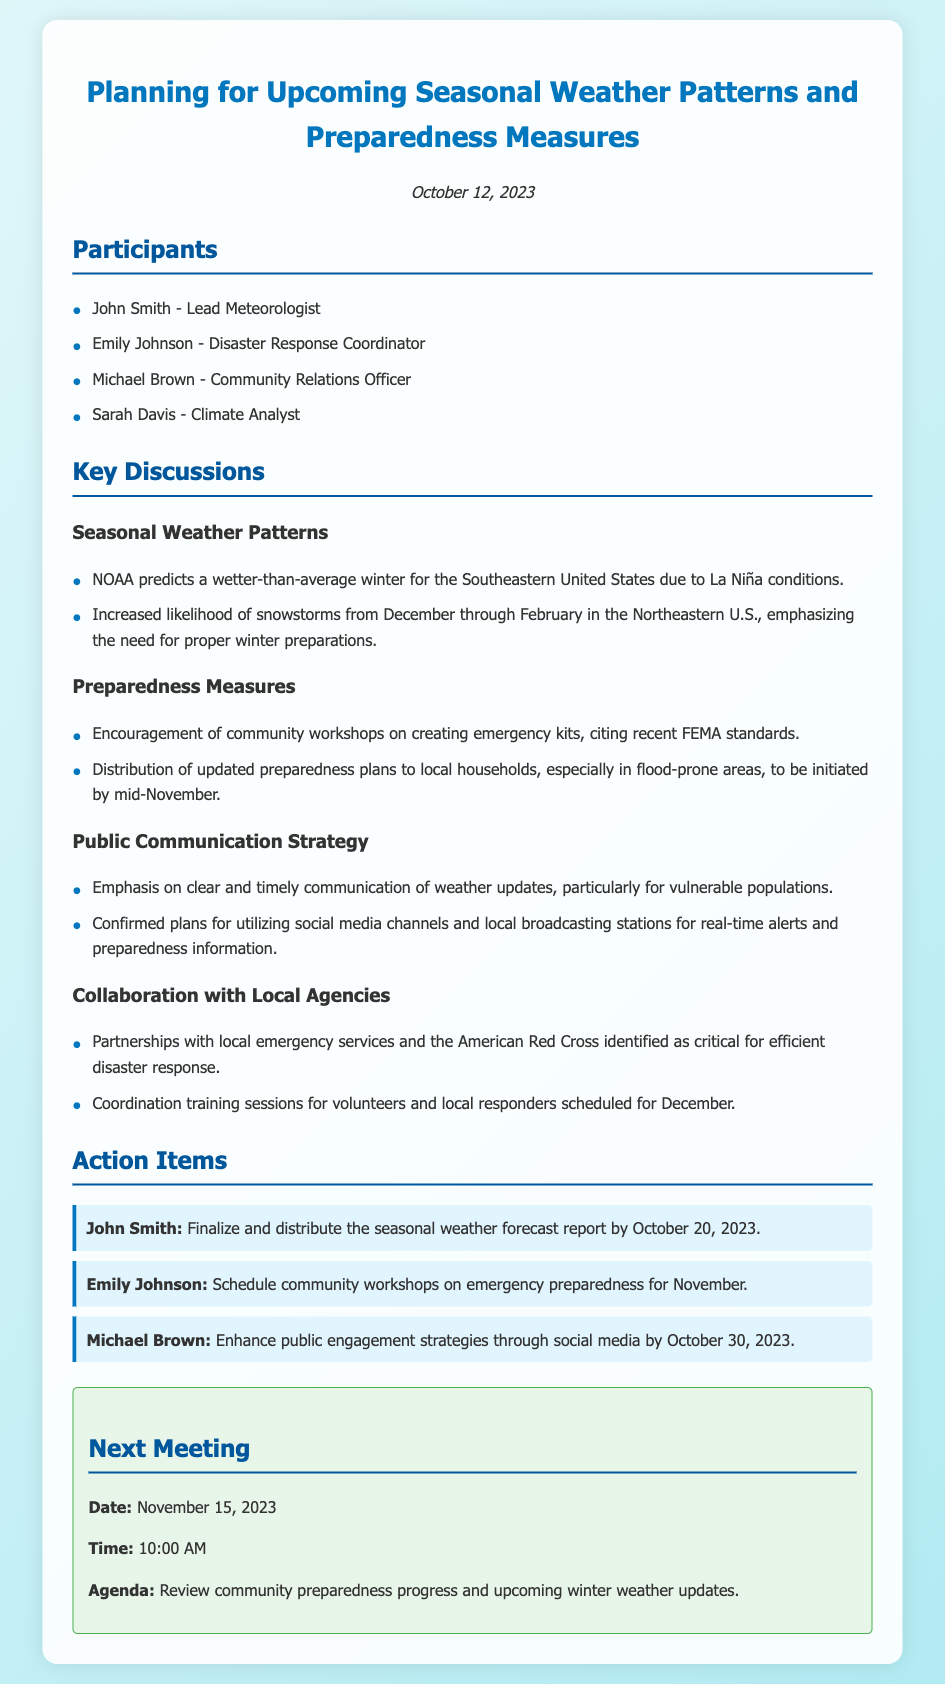What date was the meeting held? The meeting date is mentioned at the top of the document under the date section.
Answer: October 12, 2023 Who is the Lead Meteorologist? The names of participants are listed under the "Participants" section of the document.
Answer: John Smith What weather condition is predicted for the Southeastern United States? The predicted weather conditions are outlined in the first bullet under "Seasonal Weather Patterns."
Answer: Wetter-than-average winter What measures are being taken to prepare the community? The document lists specific actions under "Preparedness Measures" such as workshops and distribution of plans.
Answer: Emergency kits workshops When is the next meeting scheduled? The next meeting details are provided in the "Next Meeting" section at the end of the document.
Answer: November 15, 2023 Who is responsible for enhancing public engagement strategies? Each participant has actionable items listed under "Action Items," which identifies their responsibilities.
Answer: Michael Brown What is the purpose of the next meeting? The agenda for the next meeting is stated in the "Next Meeting" section, indicating the topics to be discussed.
Answer: Review community preparedness progress What climate condition is associated with increased snowstorms in the Northeastern U.S.? The mention of conditions leading to snowstorms can be found under "Seasonal Weather Patterns."
Answer: La Niña conditions Which agency is mentioned for partnerships in disaster response? The collaboration details in the meeting outline names specific agencies.
Answer: American Red Cross 